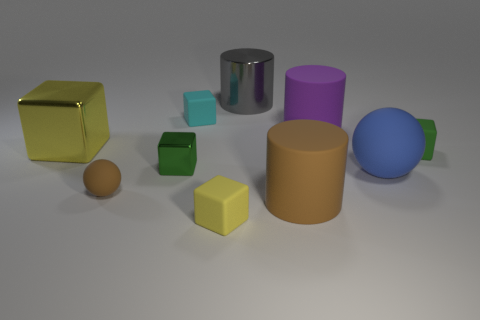The yellow thing that is the same size as the gray metal cylinder is what shape?
Your answer should be compact. Cube. Are there any small matte blocks of the same color as the large cube?
Your answer should be compact. Yes. What is the shape of the brown matte object that is to the right of the tiny shiny thing?
Offer a terse response. Cylinder. The big metal cylinder has what color?
Give a very brief answer. Gray. What is the color of the small ball that is made of the same material as the blue object?
Give a very brief answer. Brown. How many large blue spheres have the same material as the brown sphere?
Your answer should be very brief. 1. There is a purple object; what number of tiny matte balls are right of it?
Provide a short and direct response. 0. Do the tiny block that is behind the big block and the yellow thing that is right of the tiny green metallic thing have the same material?
Provide a succinct answer. Yes. Is the number of green things that are to the left of the big gray cylinder greater than the number of metallic cylinders that are in front of the brown matte cylinder?
Provide a succinct answer. Yes. What material is the object that is the same color as the tiny metallic cube?
Provide a succinct answer. Rubber. 